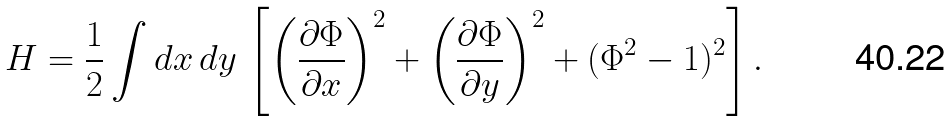Convert formula to latex. <formula><loc_0><loc_0><loc_500><loc_500>H = \frac { 1 } { 2 } \int d x \, d y \, \left [ \left ( \frac { \partial \Phi } { \partial x } \right ) ^ { 2 } + \left ( \frac { \partial \Phi } { \partial y } \right ) ^ { 2 } + ( \Phi ^ { 2 } - 1 ) ^ { 2 } \right ] .</formula> 